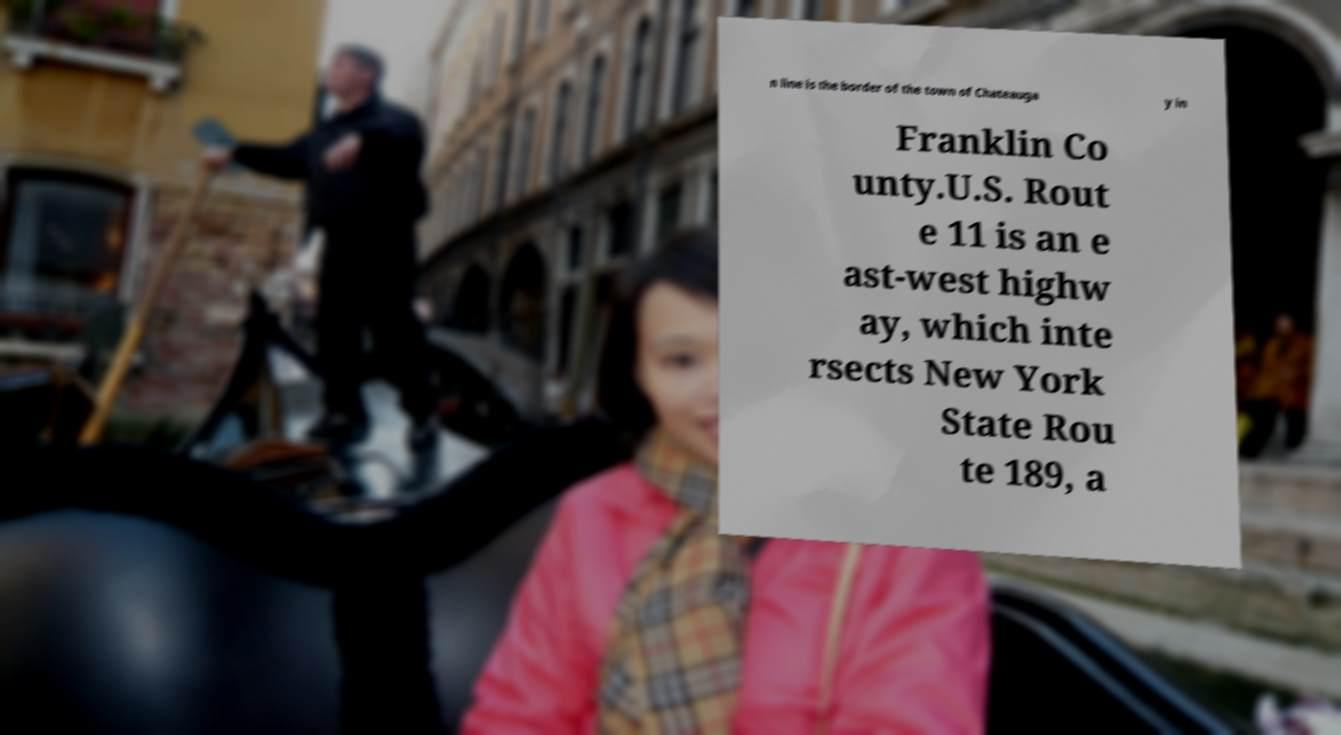What messages or text are displayed in this image? I need them in a readable, typed format. n line is the border of the town of Chateauga y in Franklin Co unty.U.S. Rout e 11 is an e ast-west highw ay, which inte rsects New York State Rou te 189, a 